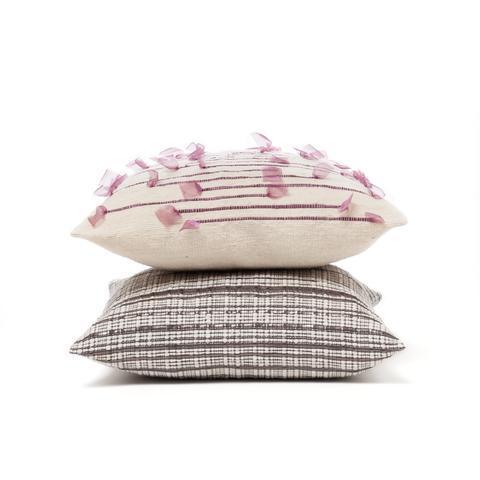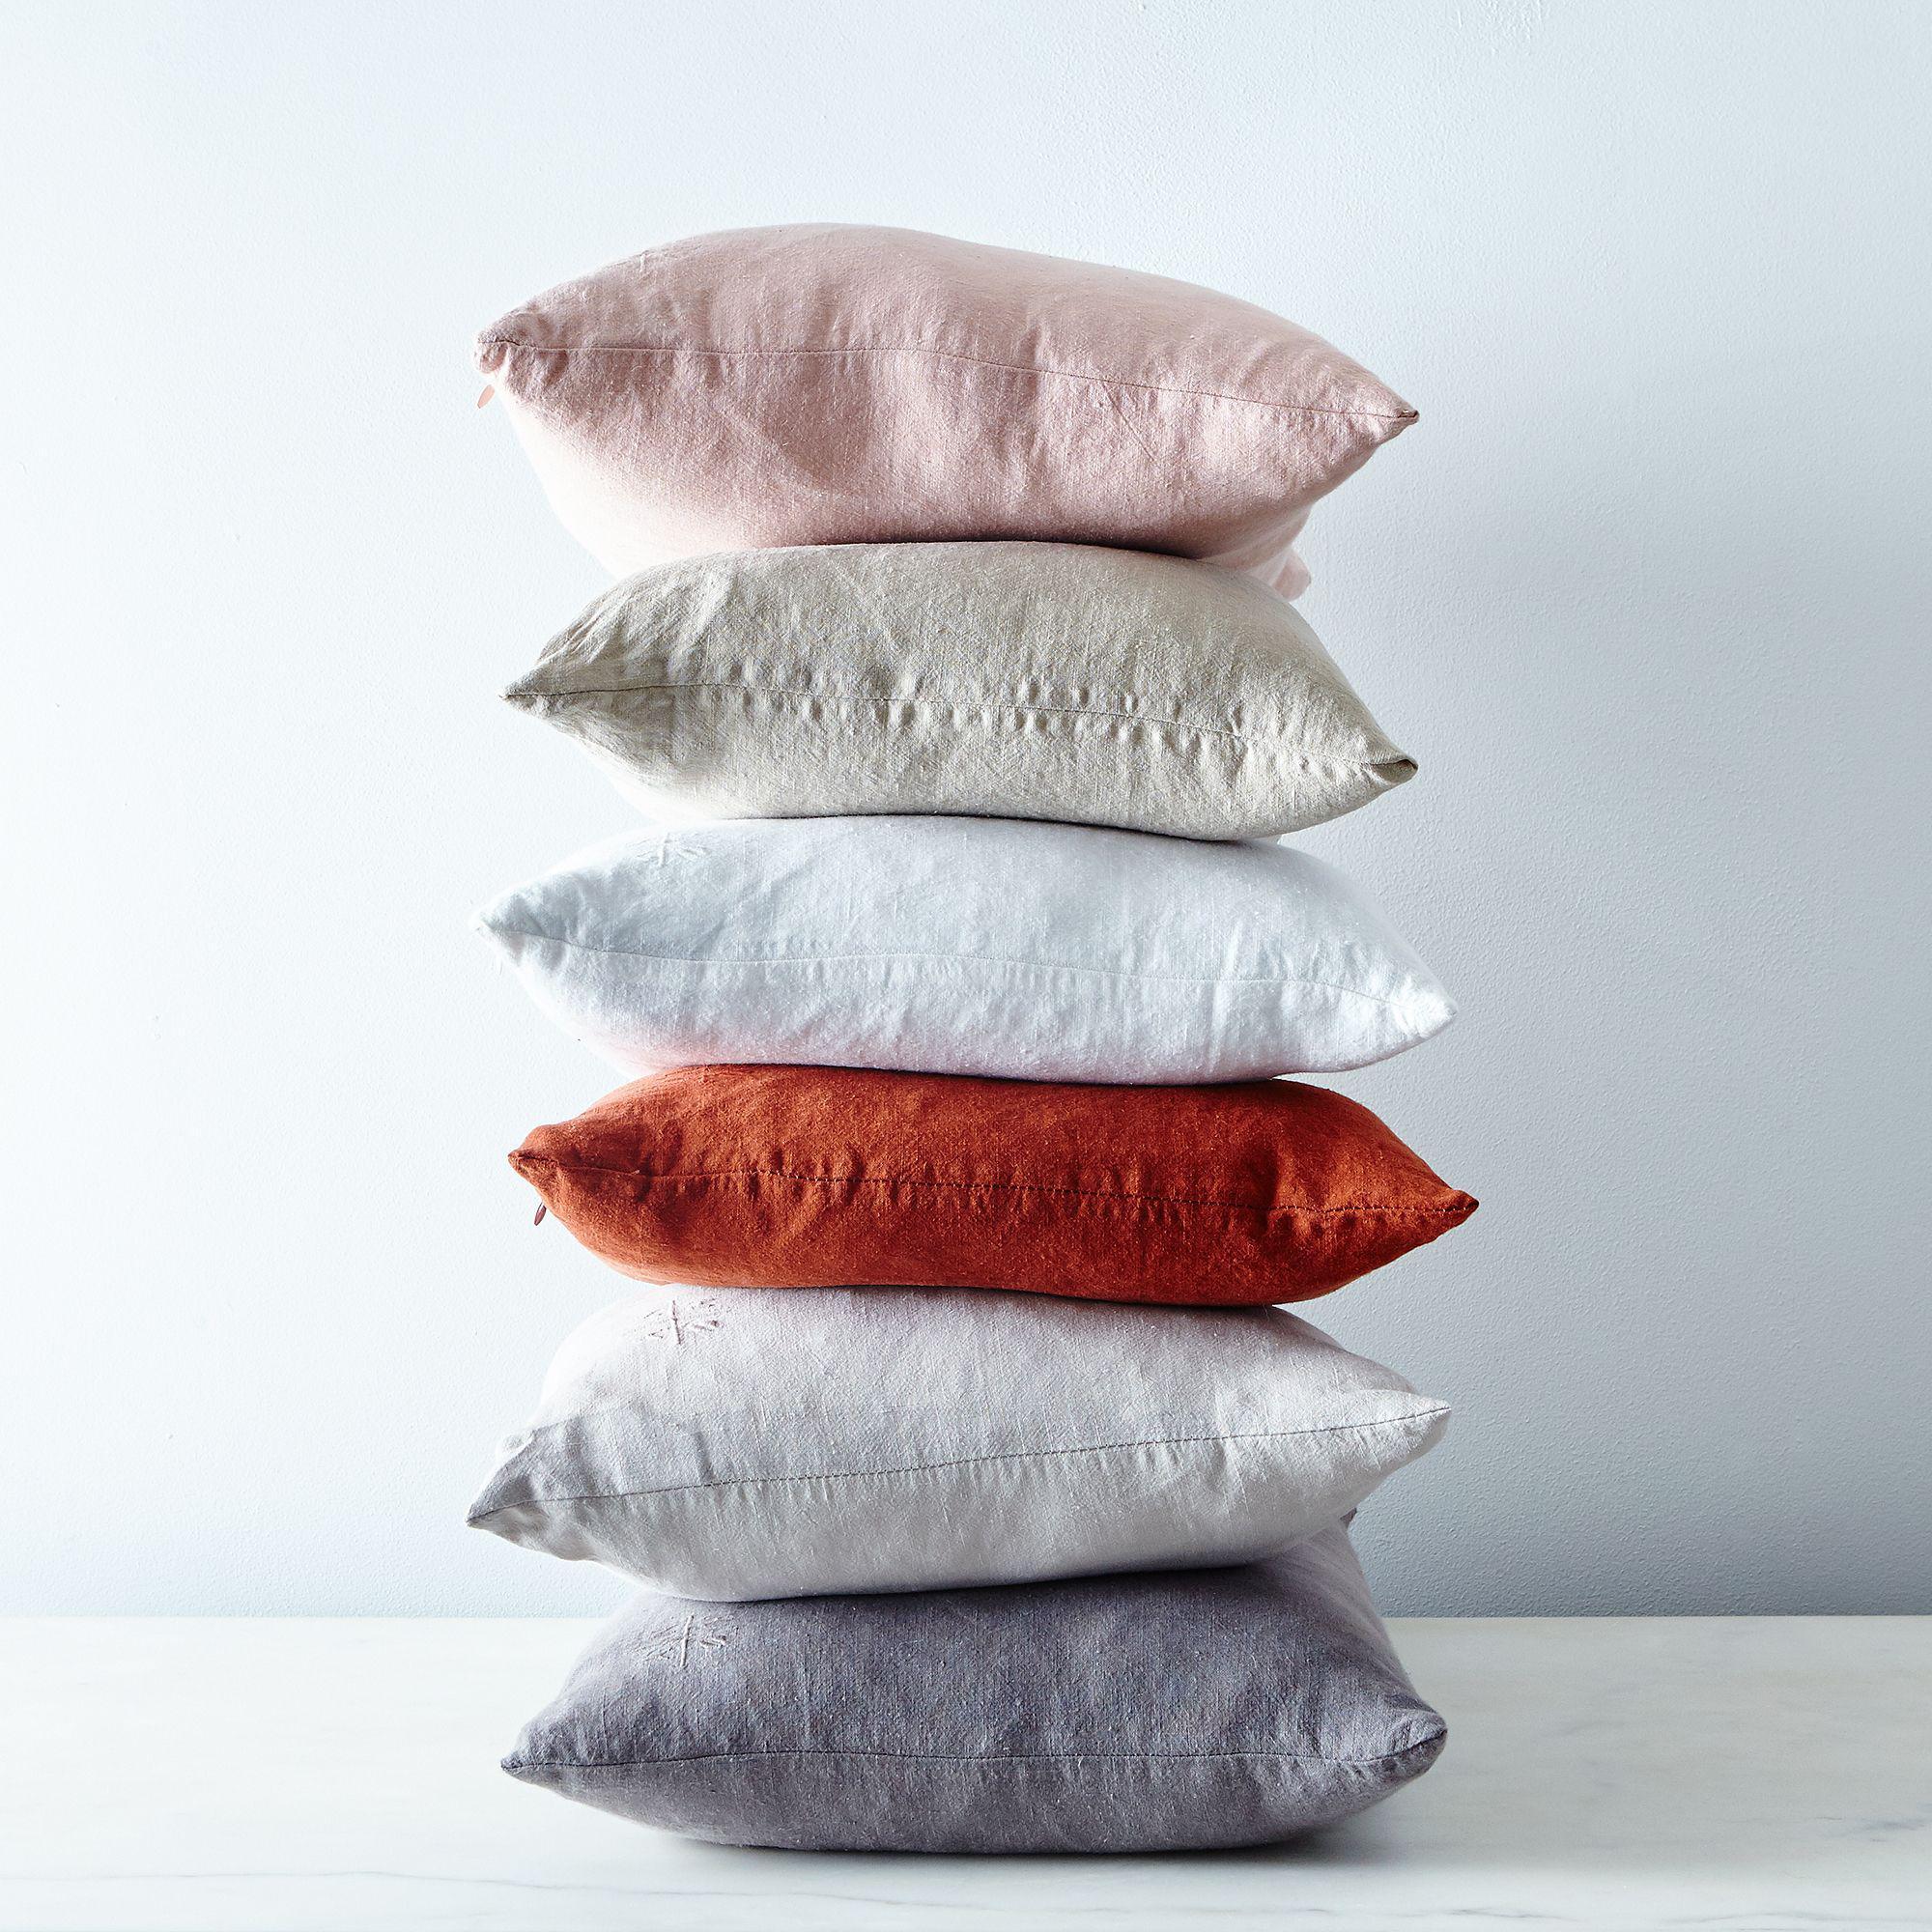The first image is the image on the left, the second image is the image on the right. Assess this claim about the two images: "In one of the images, there are exactly six square pillows stacked on top of each other.". Correct or not? Answer yes or no. Yes. The first image is the image on the left, the second image is the image on the right. For the images displayed, is the sentence "The left image includes at least one square pillow with a dimensional embellishment, and the right image includes a stack of solid and patterned pillows." factually correct? Answer yes or no. No. 